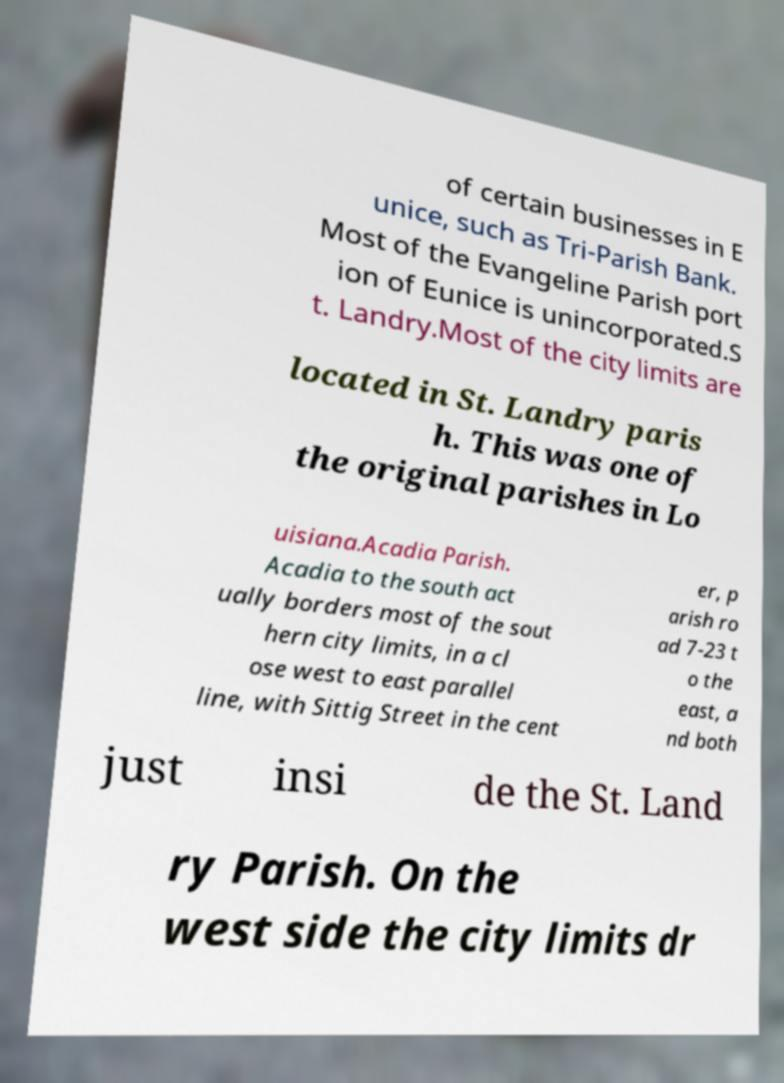Could you assist in decoding the text presented in this image and type it out clearly? of certain businesses in E unice, such as Tri-Parish Bank. Most of the Evangeline Parish port ion of Eunice is unincorporated.S t. Landry.Most of the city limits are located in St. Landry paris h. This was one of the original parishes in Lo uisiana.Acadia Parish. Acadia to the south act ually borders most of the sout hern city limits, in a cl ose west to east parallel line, with Sittig Street in the cent er, p arish ro ad 7-23 t o the east, a nd both just insi de the St. Land ry Parish. On the west side the city limits dr 